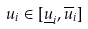Convert formula to latex. <formula><loc_0><loc_0><loc_500><loc_500>u _ { i } \in [ \underline { u } _ { i } , \overline { u } _ { i } ]</formula> 